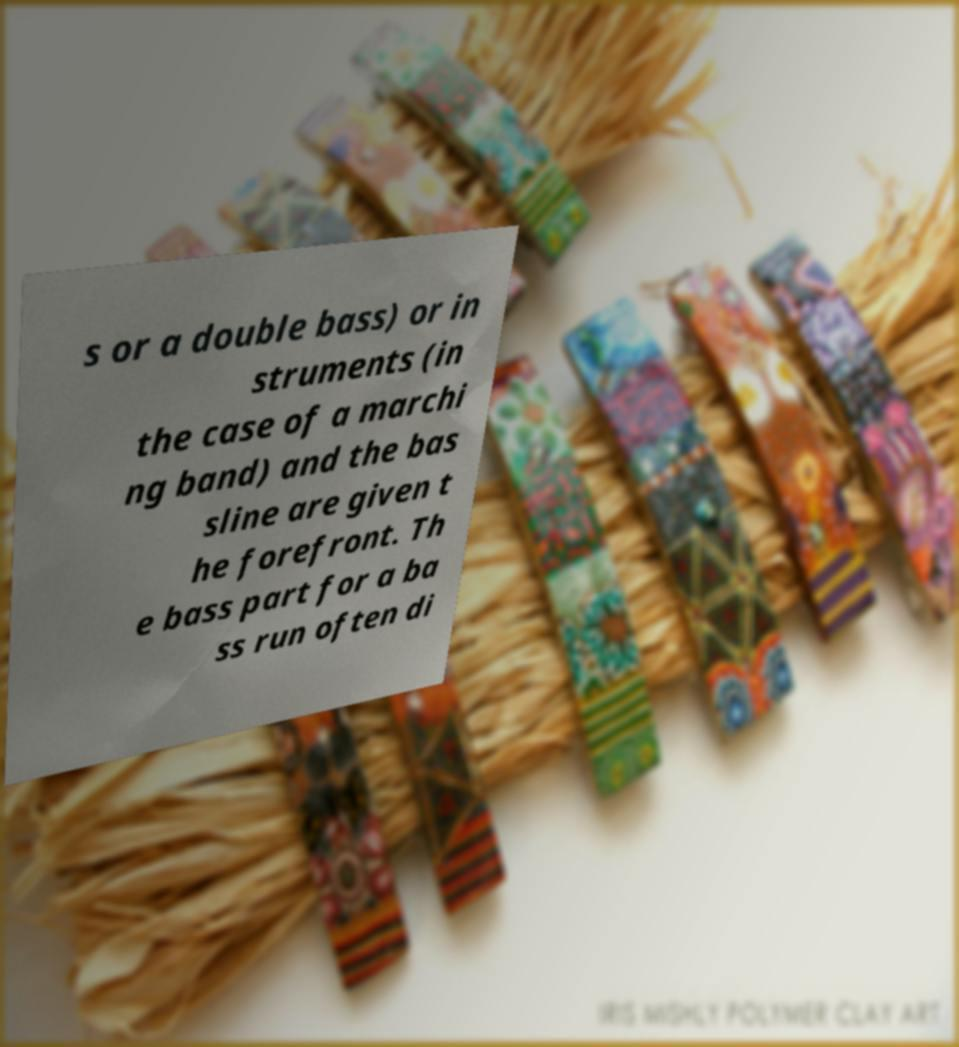Could you assist in decoding the text presented in this image and type it out clearly? s or a double bass) or in struments (in the case of a marchi ng band) and the bas sline are given t he forefront. Th e bass part for a ba ss run often di 